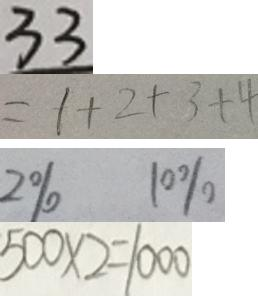<formula> <loc_0><loc_0><loc_500><loc_500>3 3 
 = 1 + 2 + 3 + 4 
 2 \% 1 0 \% 
 5 0 0 \times 2 = 1 0 0 0</formula> 